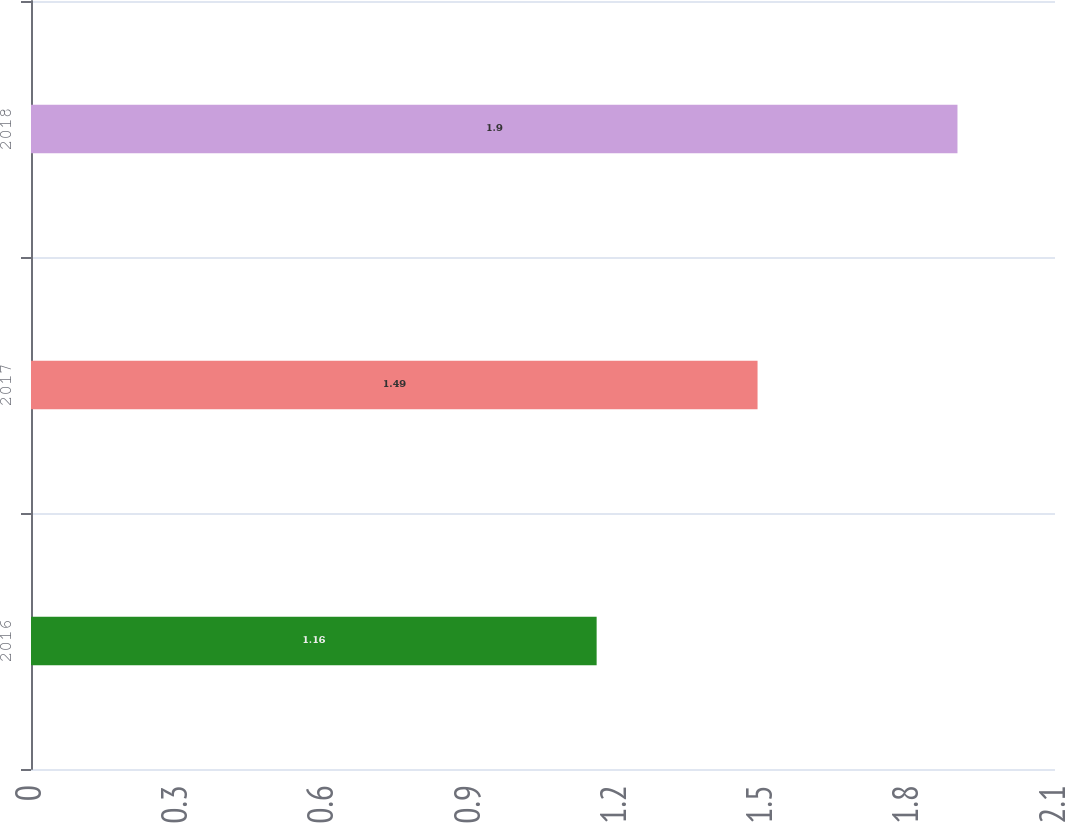<chart> <loc_0><loc_0><loc_500><loc_500><bar_chart><fcel>2016<fcel>2017<fcel>2018<nl><fcel>1.16<fcel>1.49<fcel>1.9<nl></chart> 